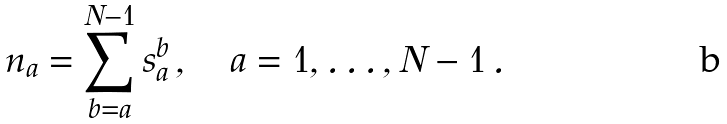<formula> <loc_0><loc_0><loc_500><loc_500>n _ { a } = \sum _ { b = a } ^ { N - 1 } s _ { a } ^ { b } \, , \quad a = 1 , \dots , N - 1 \, .</formula> 